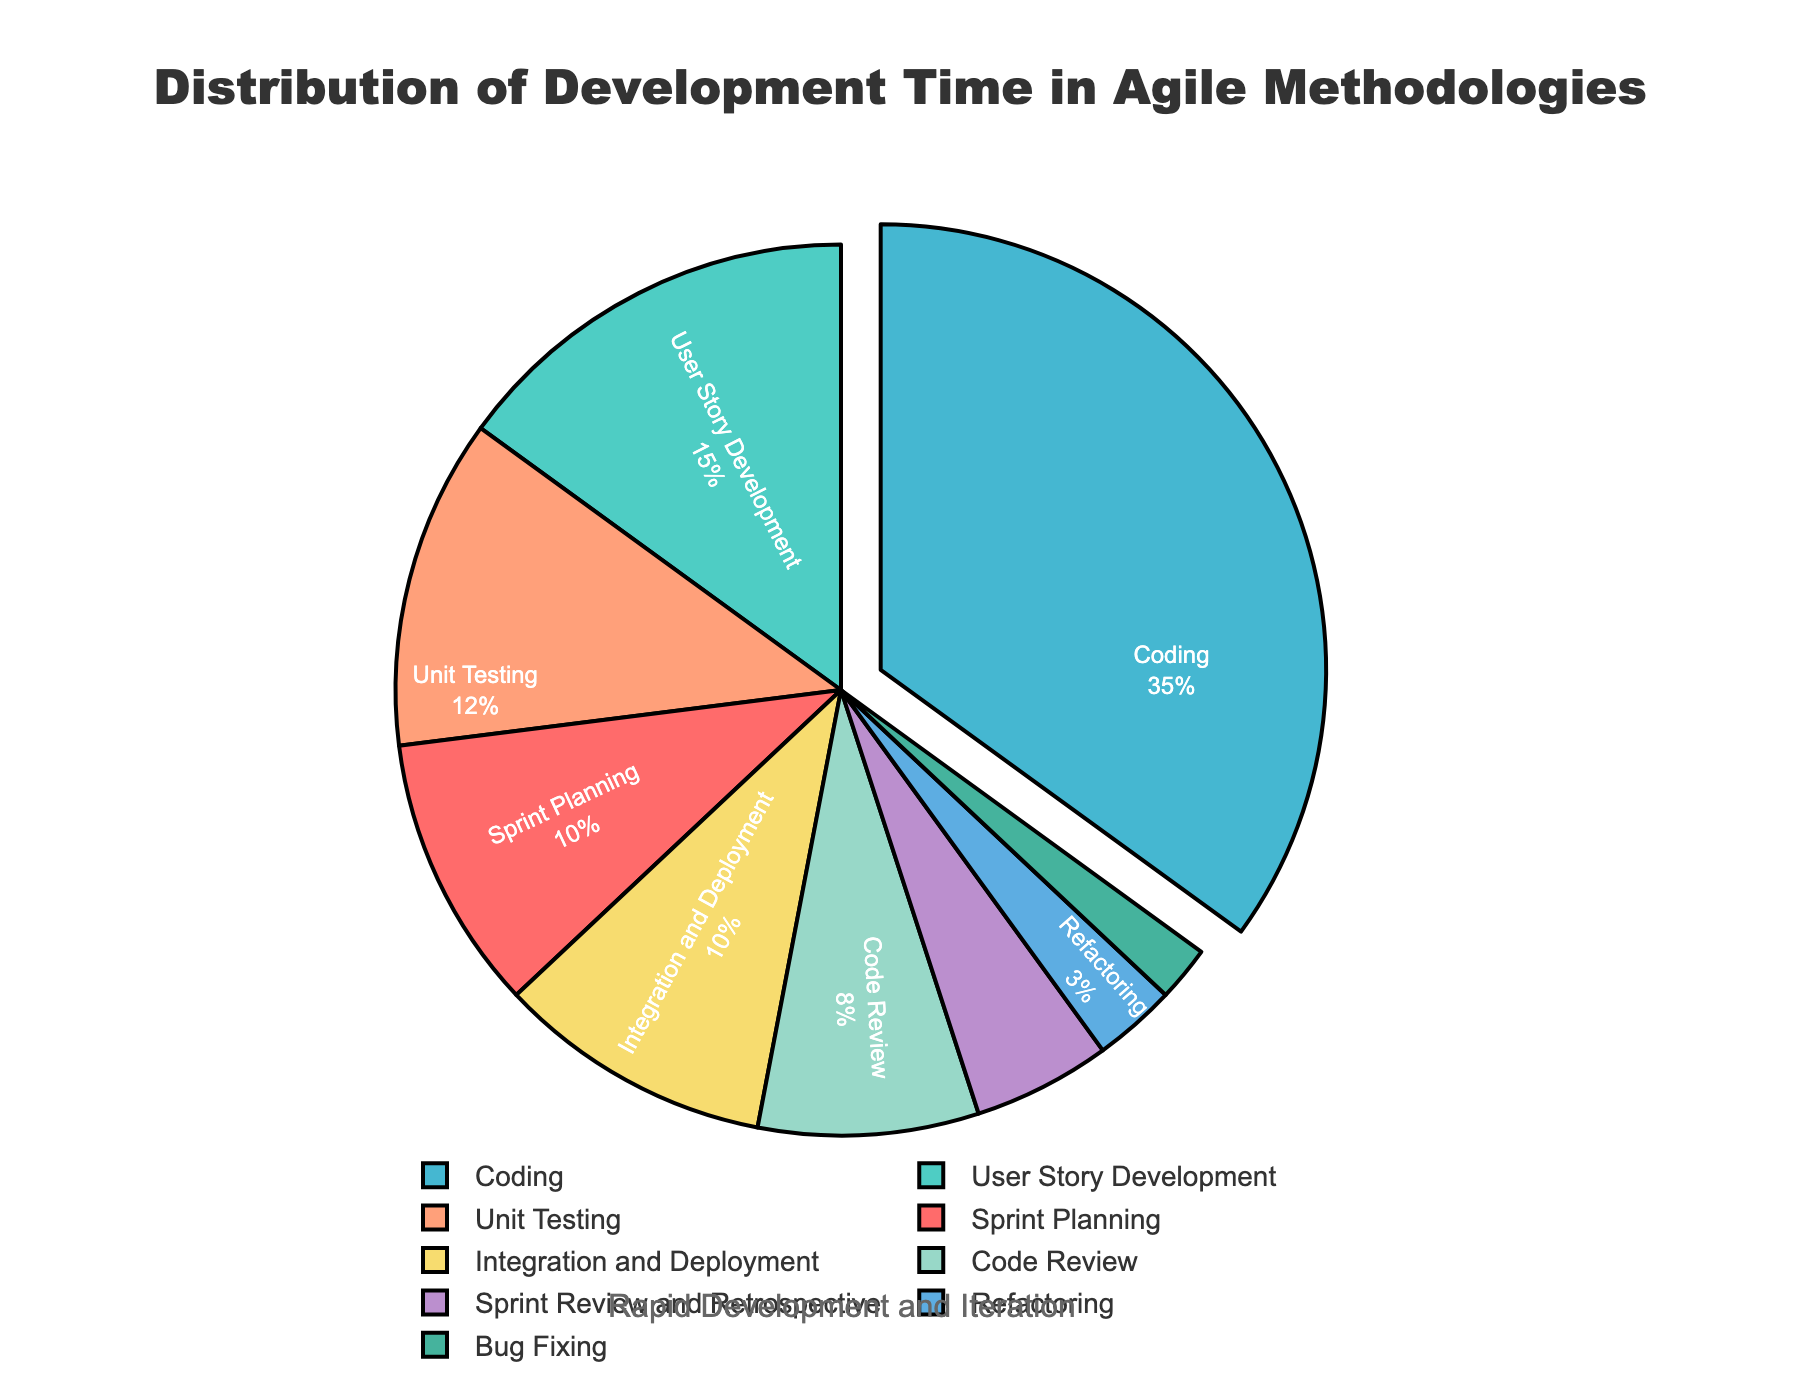Which phase takes up the largest percentage of the development time? By looking at the figure, the coding phase is emphasized by being slightly pulled out from the pie chart, indicating it has the highest percentage.
Answer: Coding How much more time percentage is spent on coding compared to user story development? First, identify the percentage for coding (35%) and user story development (15%). Then subtract the latter from the former: 35% - 15% = 20%.
Answer: 20% What is the total time percentage spent on sprint-related activities (Sprint Planning, Sprint Review and Retrospective)? Sum the percentages for Sprint Planning (10%) and Sprint Review and Retrospective (5%). So, 10% + 5% = 15%.
Answer: 15% Which phase takes the least amount of development time? By looking at the figure, the phase with the smallest slice is Bug Fixing (2%).
Answer: Bug Fixing Is more time spent on unit testing or integration and deployment? By comparing the chart, Unit Testing takes 12% while Integration and Deployment takes 10%.
Answer: Unit Testing How many phases take less than 10% of the total development time each? Count the segments that represent less than 10%: Code Review (8%), Sprint Review and Retrospective (5%), Refactoring (3%), Bug Fixing (2%). There are 4 such phases.
Answer: 4 Combine the time percentages spent on refactoring and bug fixing; is this combined percentage more or less than the time spent on sprint planning? Add the percentages for Refactoring (3%) and Bug Fixing (2%), which gives 5%. Compare this to Sprint Planning (10%). 5% is less than 10%.
Answer: Less Which phase falls between the percentages taken up by Code Review and User Story Development? Code Review takes 8%, and User Story Development takes 15%. The percentage that fits in between is Unit Testing with 12%.
Answer: Unit Testing What is the combined percentage of the two phases that spend the least time in development? Identify the two smallest percentages: Bug Fixing (2%) and Refactoring (3%). Sum them: 2% + 3% = 5%.
Answer: 5% 